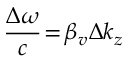<formula> <loc_0><loc_0><loc_500><loc_500>\frac { \Delta \omega } { c } \, = \, \beta _ { v } \Delta k _ { z }</formula> 